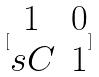<formula> <loc_0><loc_0><loc_500><loc_500>[ \begin{matrix} 1 & 0 \\ s C & 1 \end{matrix} ]</formula> 